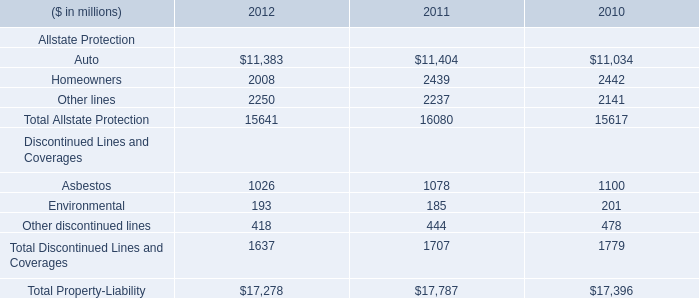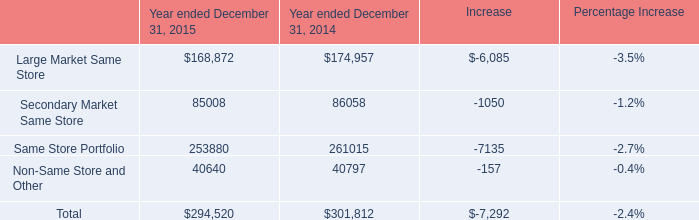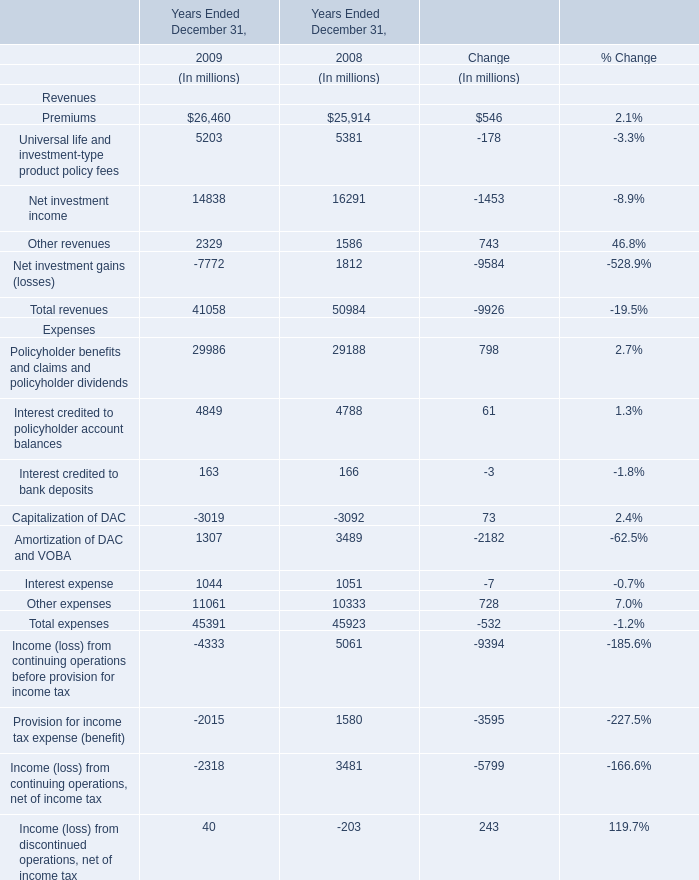What is the average amount of Other lines of 2012, and Secondary Market Same Store of Year ended December 31, 2015 ? 
Computations: ((2250.0 + 85008.0) / 2)
Answer: 43629.0. 